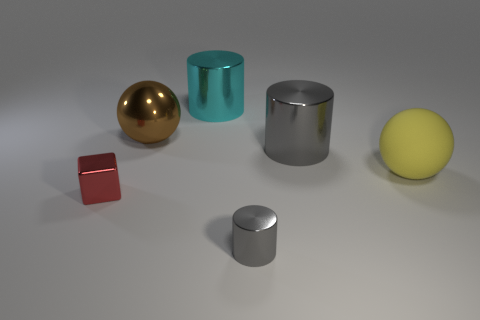Is there any other thing that is the same material as the brown thing?
Provide a succinct answer. Yes. What is the material of the small gray object that is the same shape as the large gray object?
Provide a short and direct response. Metal. What number of small things are red metal things or blue shiny things?
Provide a short and direct response. 1. Are there fewer large matte things left of the large yellow matte object than big cyan objects that are on the right side of the red shiny thing?
Offer a very short reply. Yes. What number of objects are either big metallic cylinders or blocks?
Your answer should be very brief. 3. There is a brown metal thing; how many tiny cylinders are behind it?
Ensure brevity in your answer.  0. There is a big brown thing that is made of the same material as the red cube; what is its shape?
Ensure brevity in your answer.  Sphere. Do the gray metal thing that is behind the large yellow rubber ball and the small gray thing have the same shape?
Provide a short and direct response. Yes. What number of gray objects are shiny cubes or big shiny cylinders?
Your answer should be very brief. 1. Are there the same number of big balls right of the brown ball and small gray cylinders to the left of the cyan metal object?
Your answer should be compact. No. 